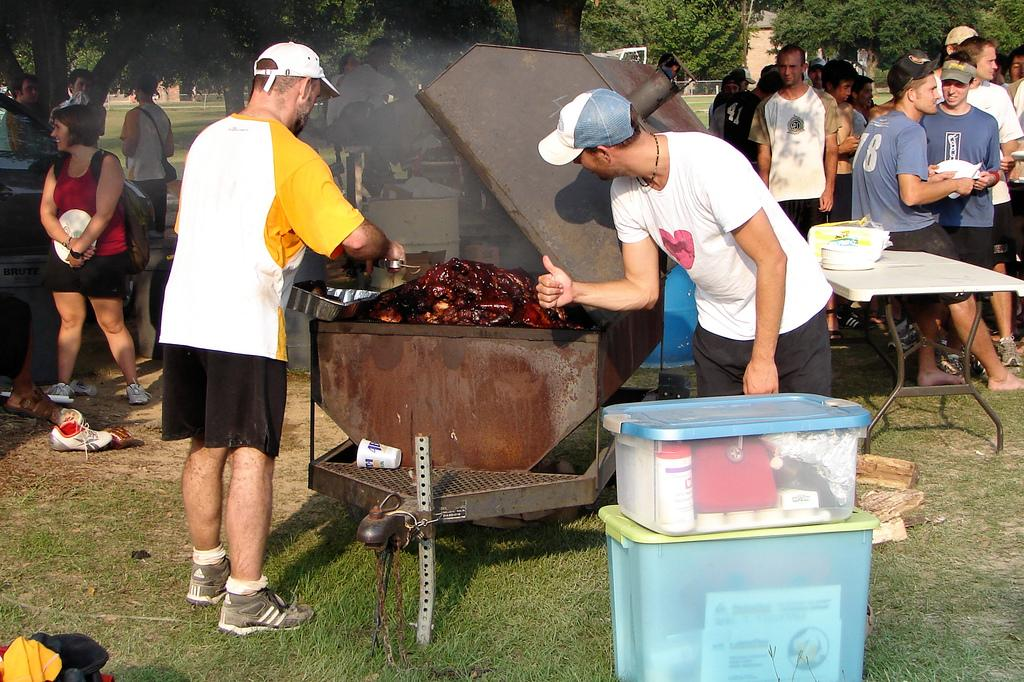Provide a one-sentence caption for the provided image. A gathering of people at a barbecue and one man with a number 18 on his shirt. 